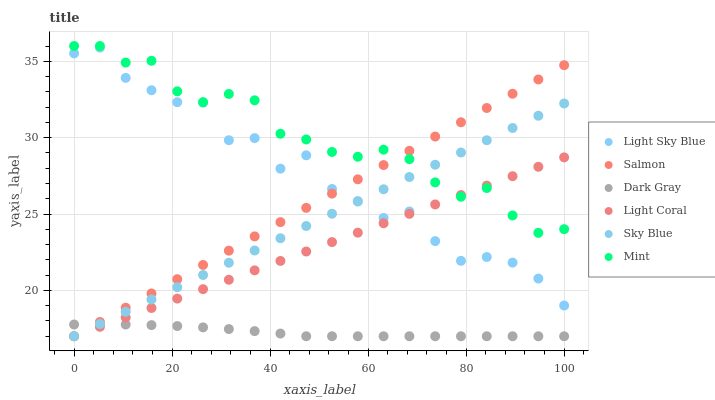Does Dark Gray have the minimum area under the curve?
Answer yes or no. Yes. Does Mint have the maximum area under the curve?
Answer yes or no. Yes. Does Salmon have the minimum area under the curve?
Answer yes or no. No. Does Salmon have the maximum area under the curve?
Answer yes or no. No. Is Light Coral the smoothest?
Answer yes or no. Yes. Is Light Sky Blue the roughest?
Answer yes or no. Yes. Is Salmon the smoothest?
Answer yes or no. No. Is Salmon the roughest?
Answer yes or no. No. Does Light Coral have the lowest value?
Answer yes or no. Yes. Does Light Sky Blue have the lowest value?
Answer yes or no. No. Does Mint have the highest value?
Answer yes or no. Yes. Does Salmon have the highest value?
Answer yes or no. No. Is Dark Gray less than Mint?
Answer yes or no. Yes. Is Mint greater than Dark Gray?
Answer yes or no. Yes. Does Dark Gray intersect Sky Blue?
Answer yes or no. Yes. Is Dark Gray less than Sky Blue?
Answer yes or no. No. Is Dark Gray greater than Sky Blue?
Answer yes or no. No. Does Dark Gray intersect Mint?
Answer yes or no. No. 